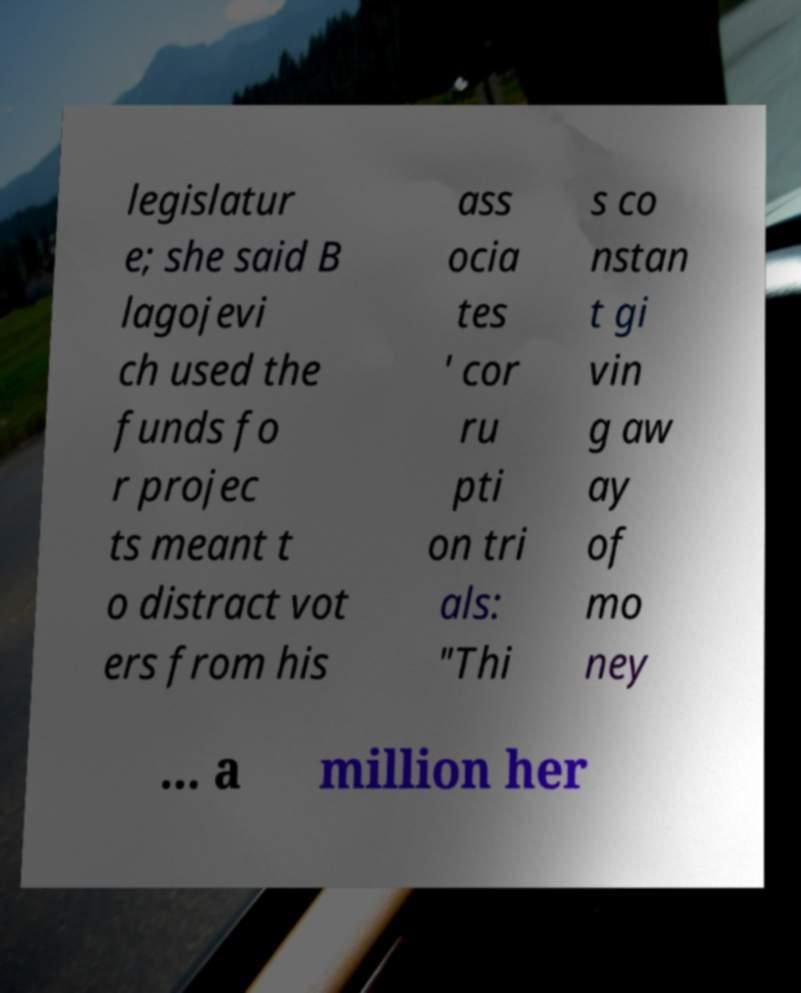For documentation purposes, I need the text within this image transcribed. Could you provide that? legislatur e; she said B lagojevi ch used the funds fo r projec ts meant t o distract vot ers from his ass ocia tes ' cor ru pti on tri als: "Thi s co nstan t gi vin g aw ay of mo ney ... a million her 